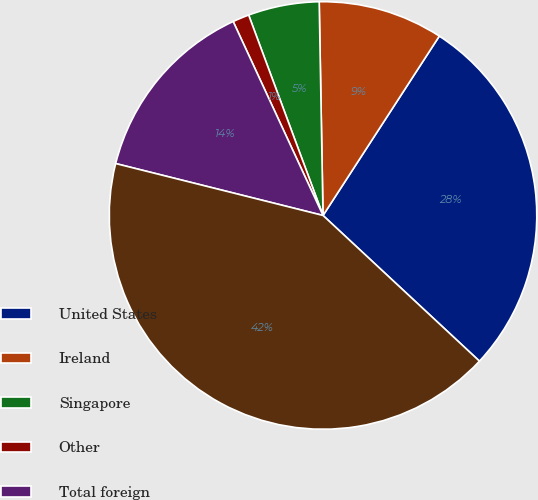<chart> <loc_0><loc_0><loc_500><loc_500><pie_chart><fcel>United States<fcel>Ireland<fcel>Singapore<fcel>Other<fcel>Total foreign<fcel>Worldwide total<nl><fcel>27.78%<fcel>9.44%<fcel>5.37%<fcel>1.25%<fcel>14.19%<fcel>41.97%<nl></chart> 